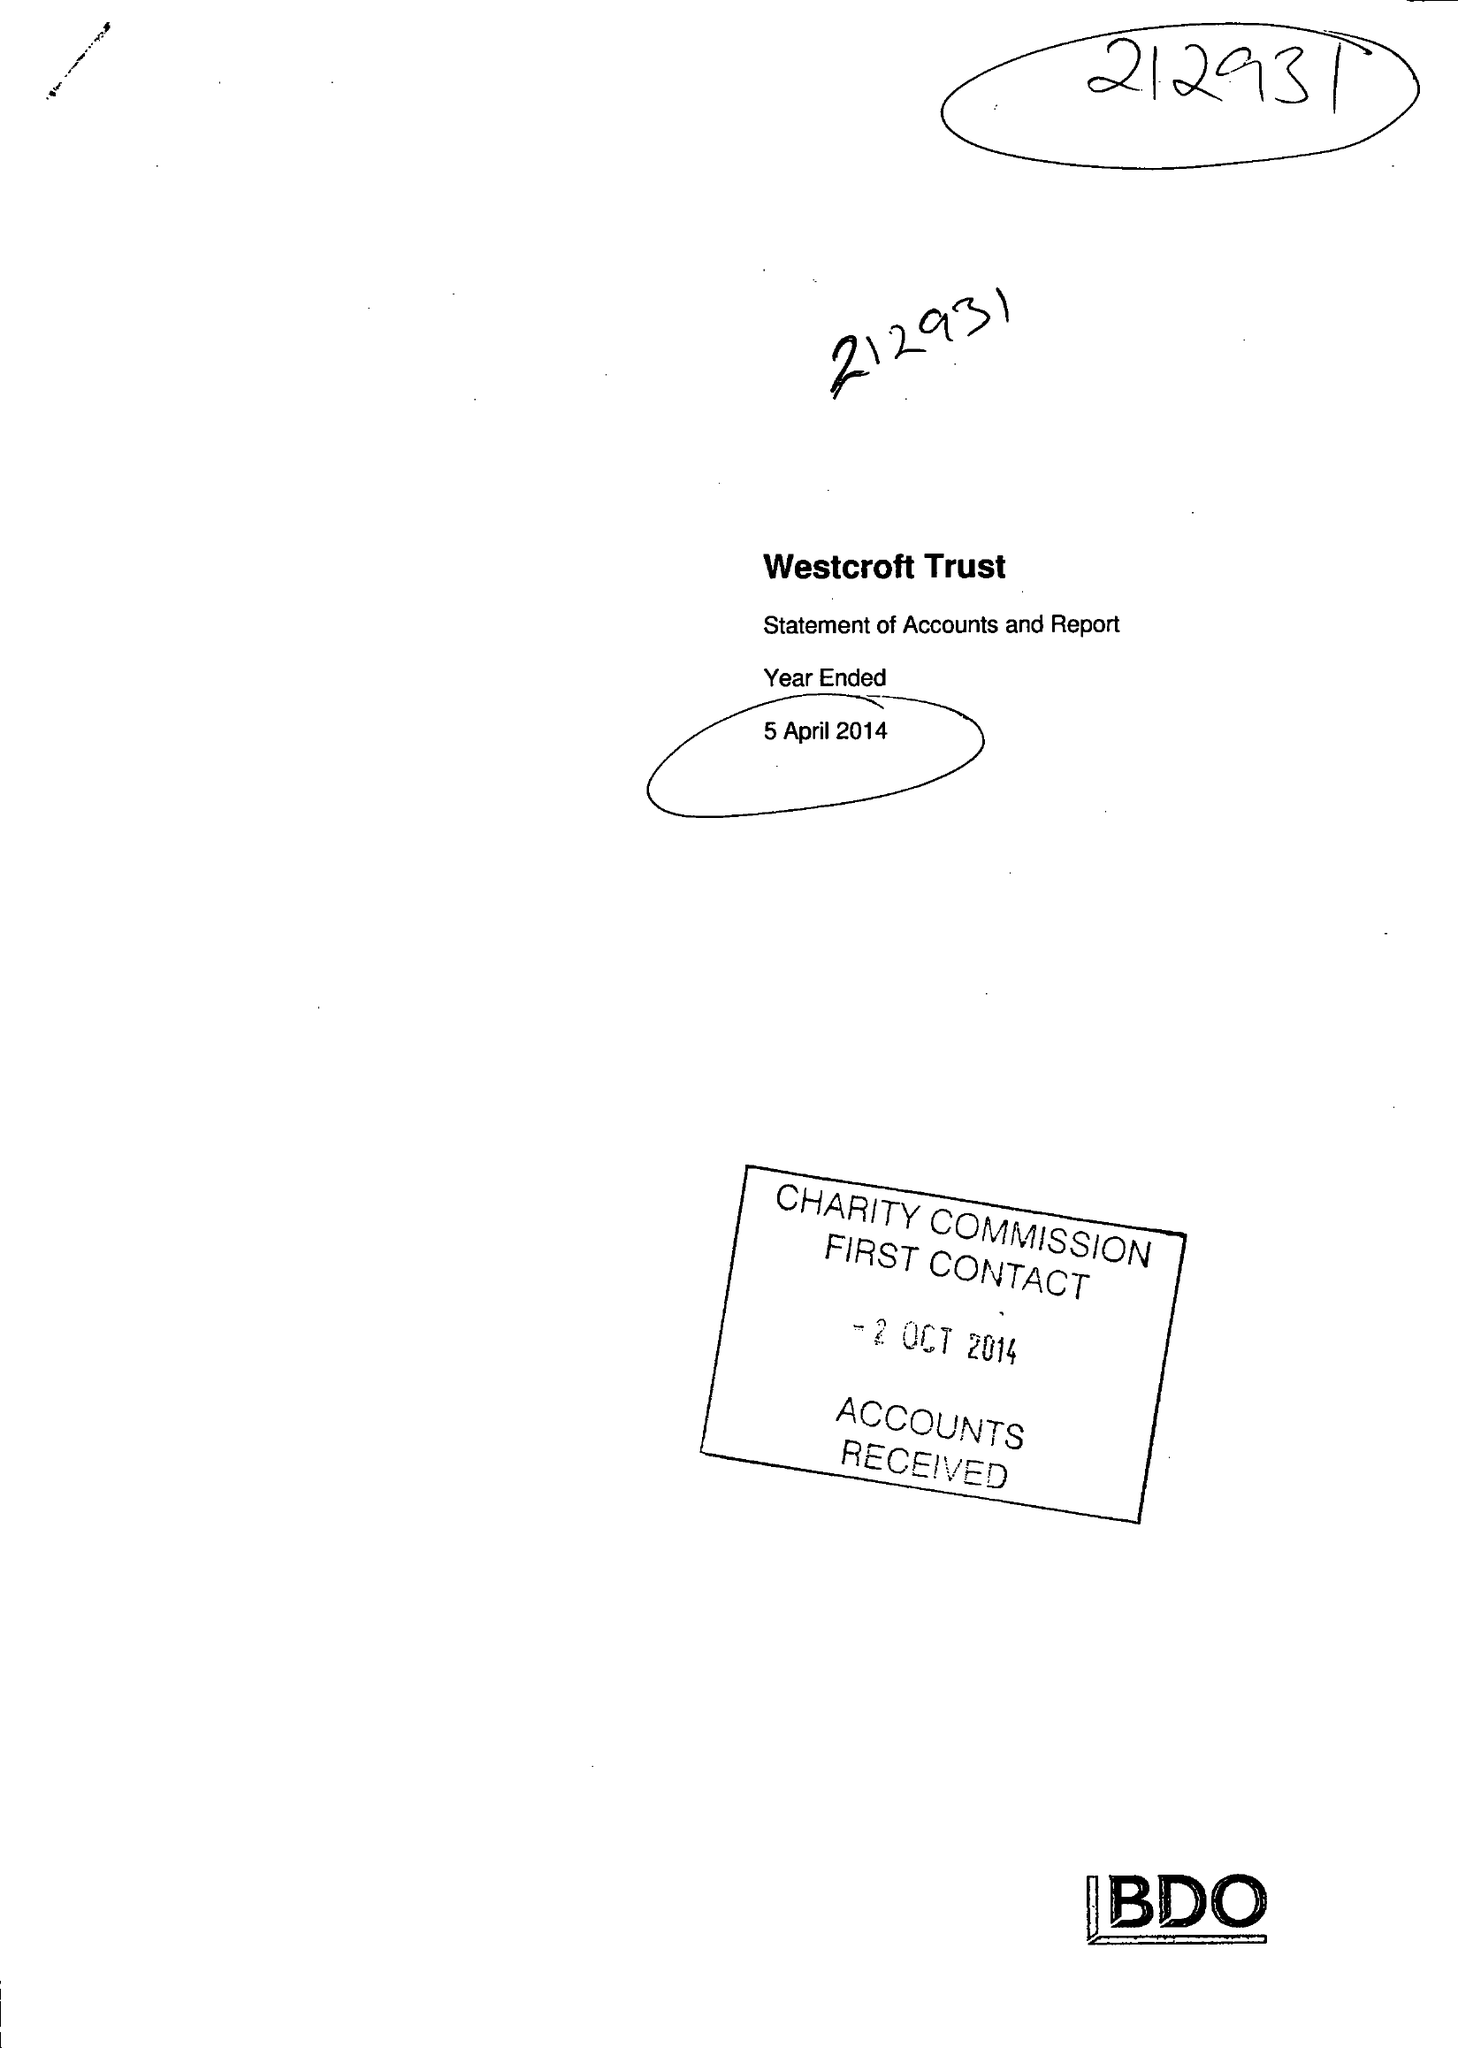What is the value for the address__street_line?
Answer the question using a single word or phrase. 32 HAMPTON ROAD 